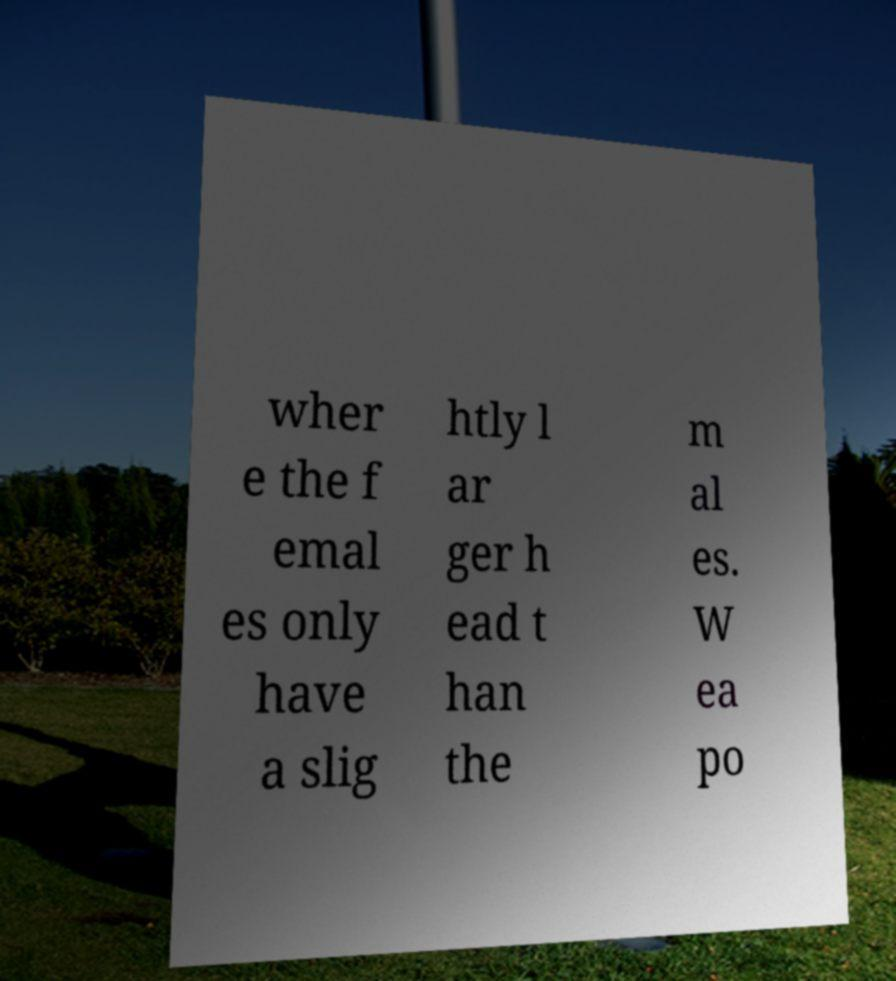For documentation purposes, I need the text within this image transcribed. Could you provide that? wher e the f emal es only have a slig htly l ar ger h ead t han the m al es. W ea po 